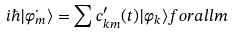Convert formula to latex. <formula><loc_0><loc_0><loc_500><loc_500>i \hbar { | } \dot { \varphi _ { m } } \rangle = \sum c ^ { \prime } _ { k m } ( t ) | \varphi _ { k } \rangle f o r a l l m</formula> 